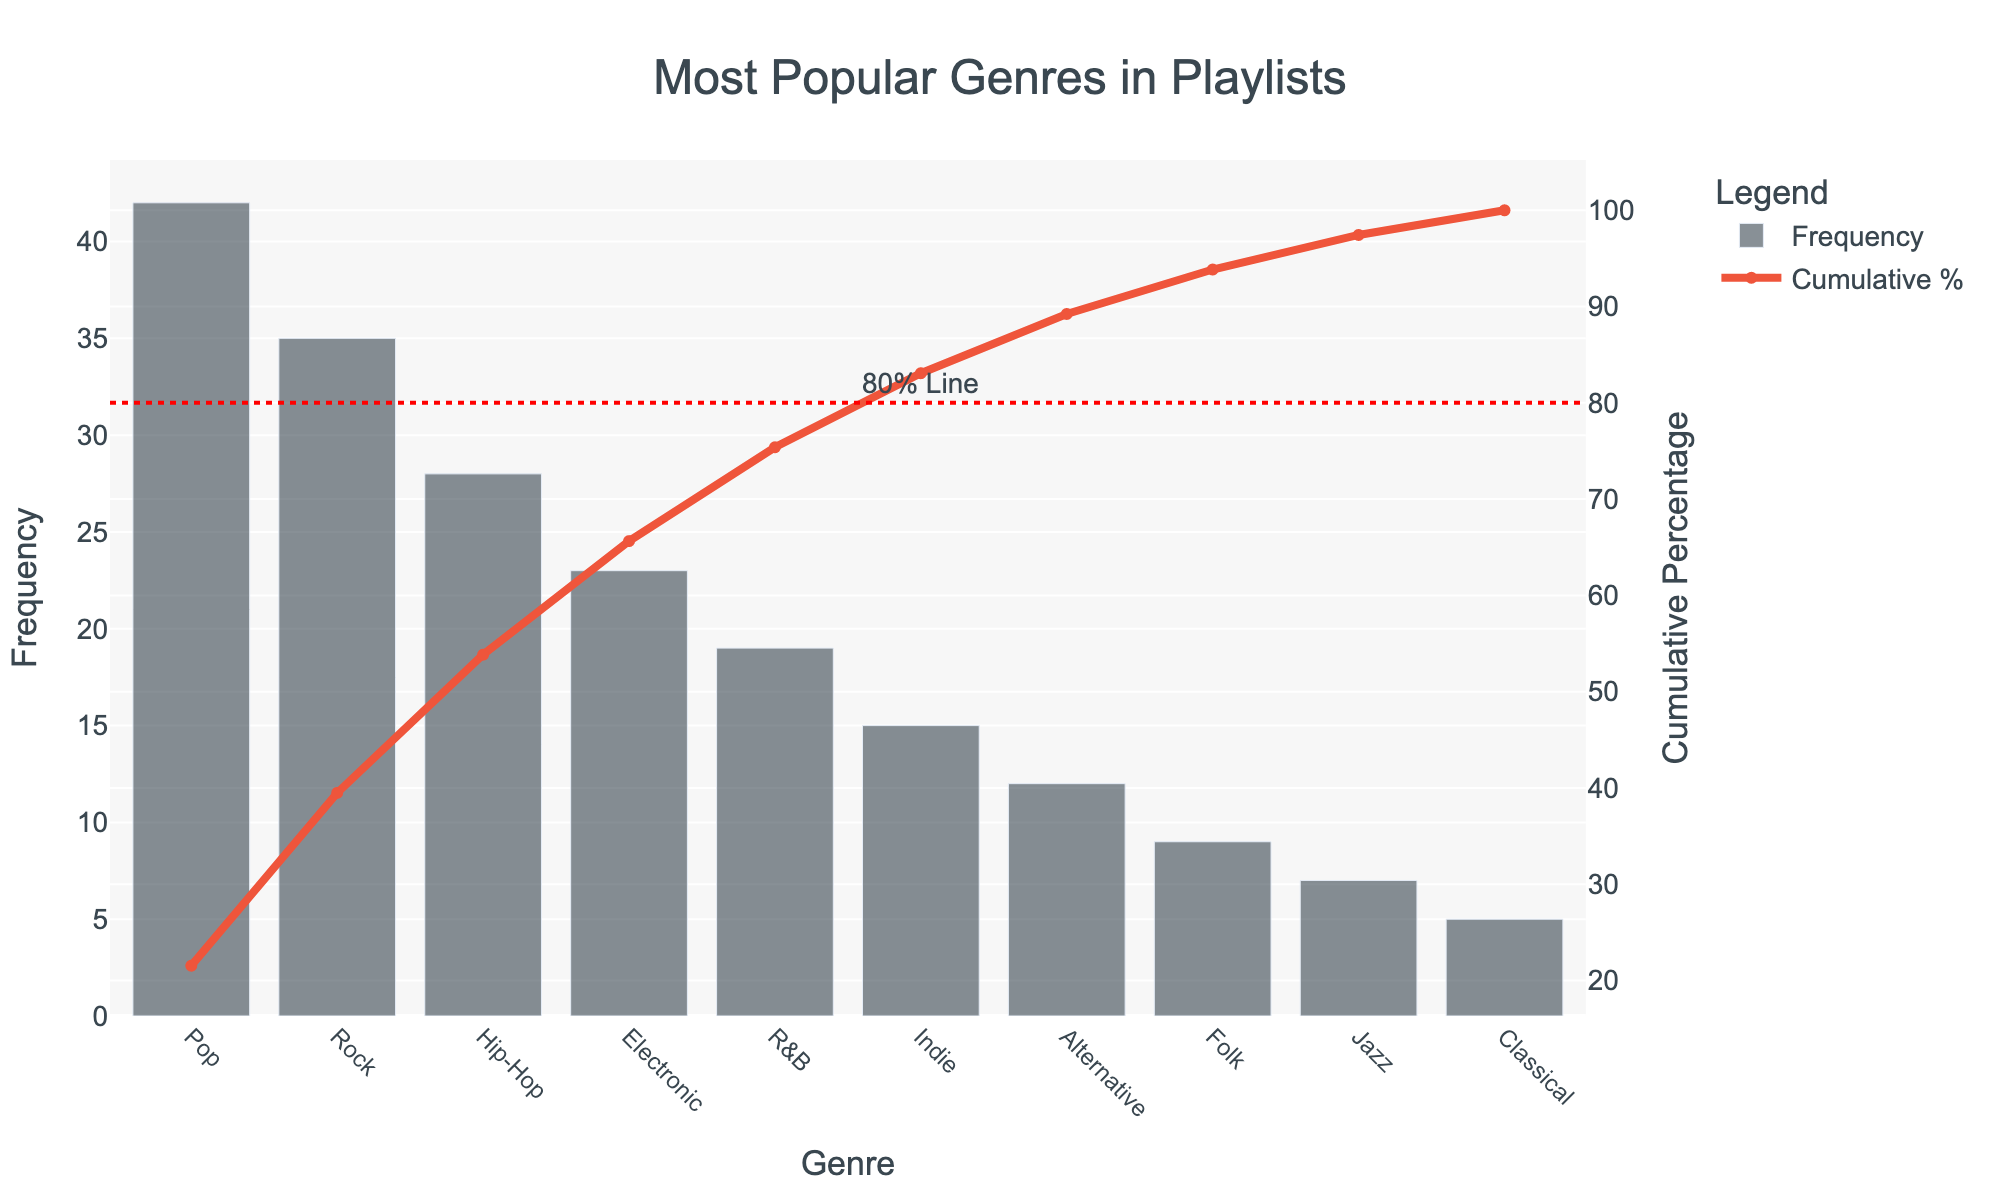What is the most popular genre in the playlists? The most popular genre is identified by locating the bar with the highest frequency on the chart. In this case, the genre at the left of the chart, labeled "Pop," has the highest frequency with a value of 42.
Answer: Pop What is the frequency of the least popular genre? To find the frequency of the least popular genre, look at the genre with the shortest bar on the chart. The genre "Classical" is at the far right with a frequency of 5.
Answer: 5 Which genres make up the top 20% highest frequencies? The top 20% of highest frequencies correspond to the genres left of the 80% cumulative percentage mark, as shown by the red 80% reference line. The first three genres listed, "Pop," "Rock," and "Hip-Hop," fall within this range.
Answer: Pop, Rock, Hip-Hop How many genres contribute to at least 80% of the total playlist? Identify the point where the cumulative percentage curve meets or exceeds 80%. Viewing the x-axis alignment with the 80% line, genres up to and including "Electronic" make the cumulative percentage equal to or exceed 80%.
Answer: 4 What is the cumulative percentage of "Indie"? Locate the "Indie" genre on the x-axis. The line chart above it represents the cumulative percentage, which is approximately 80%, given its alignment close to this value.
Answer: Approx. 80% By how much does "Rock" exceed "Electronic" in frequency? Find the frequency of "Rock" (35) and the frequency of "Electronic" (23). Subtract the smaller value from the larger one for the difference: 35 - 23 = 12.
Answer: 12 What is the cumulative percentage difference between "Pop" and "Jazz"? The cumulative percentage for "Pop" is at its individual value, and for "Jazz," it's cumulative up to its point. "Pop" is approximately 19%, and "Jazz" reaches about 94%, so 94% - 19% = 75%.
Answer: 75% Which genre has a frequency less than 15 but more than 10? Look at the bars representing frequencies within the given range. "Alternative," with a frequency of 12, meets this criterion.
Answer: Alternative How does the frequency of "R&B" compare to "Folk"? The frequency of "R&B" (19) compared to "Folk" (9) shows that "R&B" is higher. 19 > 9.
Answer: R&B is higher than Folk What percentage of the total does "Hip-Hop" contribute individually? Find the frequency of "Hip-Hop" (28) and divide by the total sum of frequencies (42 + 35 + 28 + 23 + 19 + 15 + 12 + 9 + 7 + 5 = 195), then multiply by 100 to convert to a percentage: (28 / 195) * 100 ≈ 14.36%.
Answer: Approx. 14.36% 